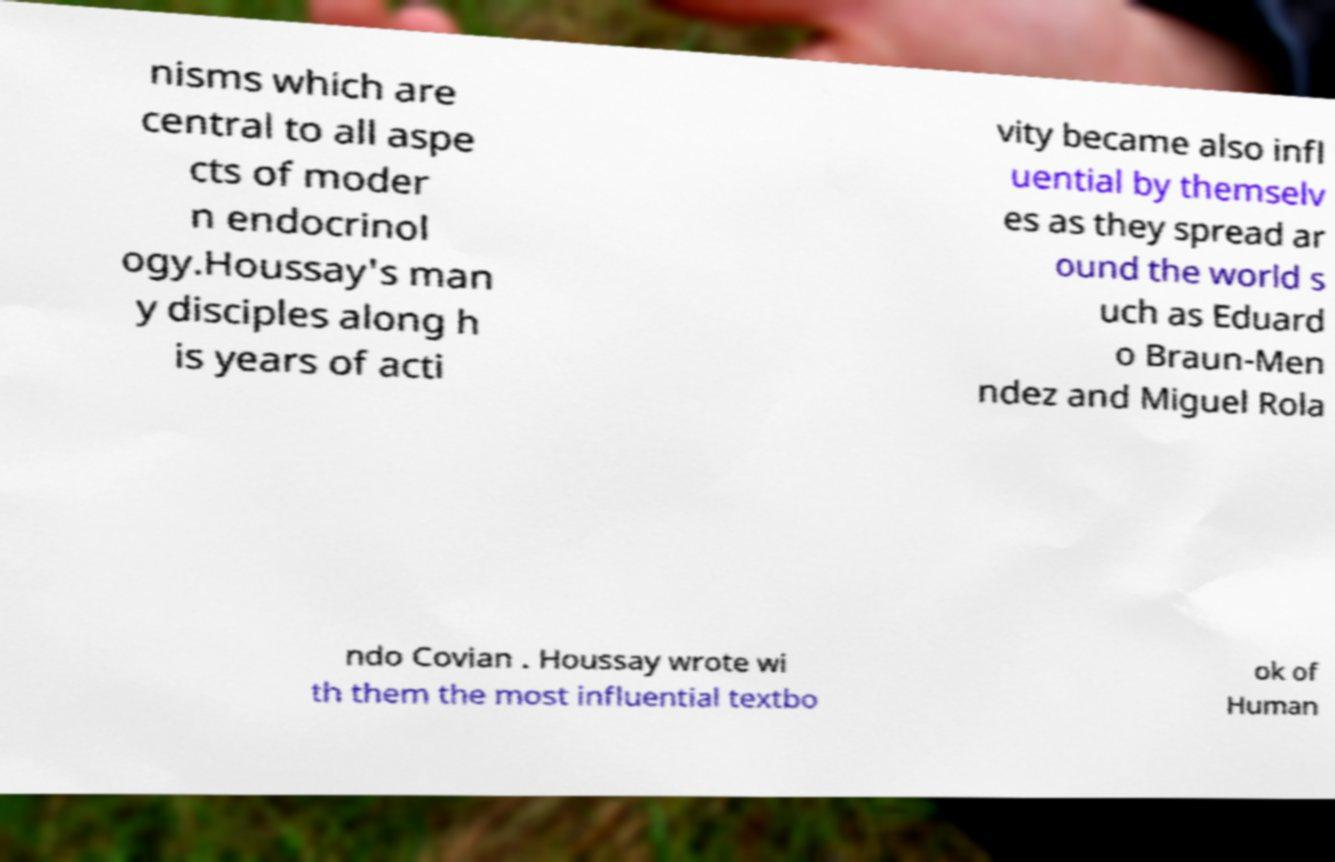For documentation purposes, I need the text within this image transcribed. Could you provide that? nisms which are central to all aspe cts of moder n endocrinol ogy.Houssay's man y disciples along h is years of acti vity became also infl uential by themselv es as they spread ar ound the world s uch as Eduard o Braun-Men ndez and Miguel Rola ndo Covian . Houssay wrote wi th them the most influential textbo ok of Human 